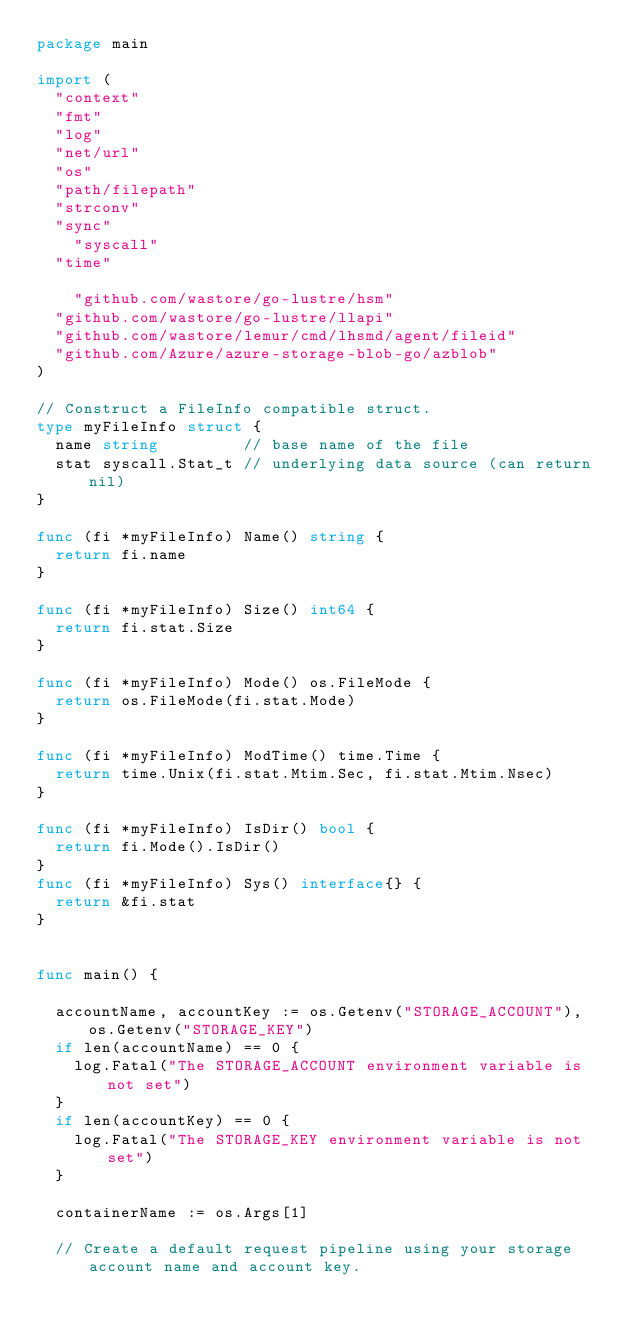<code> <loc_0><loc_0><loc_500><loc_500><_Go_>package main

import (
	"context"
	"fmt"
	"log"
	"net/url"
	"os"
	"path/filepath"
	"strconv"
	"sync"
    "syscall"
	"time"

    "github.com/wastore/go-lustre/hsm"
	"github.com/wastore/go-lustre/llapi"
	"github.com/wastore/lemur/cmd/lhsmd/agent/fileid"
	"github.com/Azure/azure-storage-blob-go/azblob"
)

// Construct a FileInfo compatible struct.
type myFileInfo struct {
	name string         // base name of the file
	stat syscall.Stat_t // underlying data source (can return nil)
}

func (fi *myFileInfo) Name() string {
	return fi.name
}

func (fi *myFileInfo) Size() int64 {
	return fi.stat.Size
}

func (fi *myFileInfo) Mode() os.FileMode {
	return os.FileMode(fi.stat.Mode)
}

func (fi *myFileInfo) ModTime() time.Time {
	return time.Unix(fi.stat.Mtim.Sec, fi.stat.Mtim.Nsec)
}

func (fi *myFileInfo) IsDir() bool {
	return fi.Mode().IsDir()
}
func (fi *myFileInfo) Sys() interface{} {
	return &fi.stat
}


func main() {

	accountName, accountKey := os.Getenv("STORAGE_ACCOUNT"), os.Getenv("STORAGE_KEY")
	if len(accountName) == 0 {
		log.Fatal("The STORAGE_ACCOUNT environment variable is not set")
	}
	if len(accountKey) == 0 {
		log.Fatal("The STORAGE_KEY environment variable is not set")
	}

	containerName := os.Args[1]

	// Create a default request pipeline using your storage account name and account key.</code> 